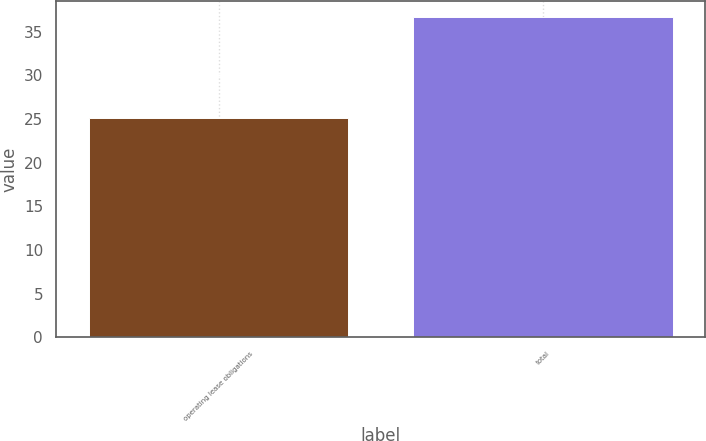Convert chart. <chart><loc_0><loc_0><loc_500><loc_500><bar_chart><fcel>operating lease obligations<fcel>total<nl><fcel>25.1<fcel>36.7<nl></chart> 